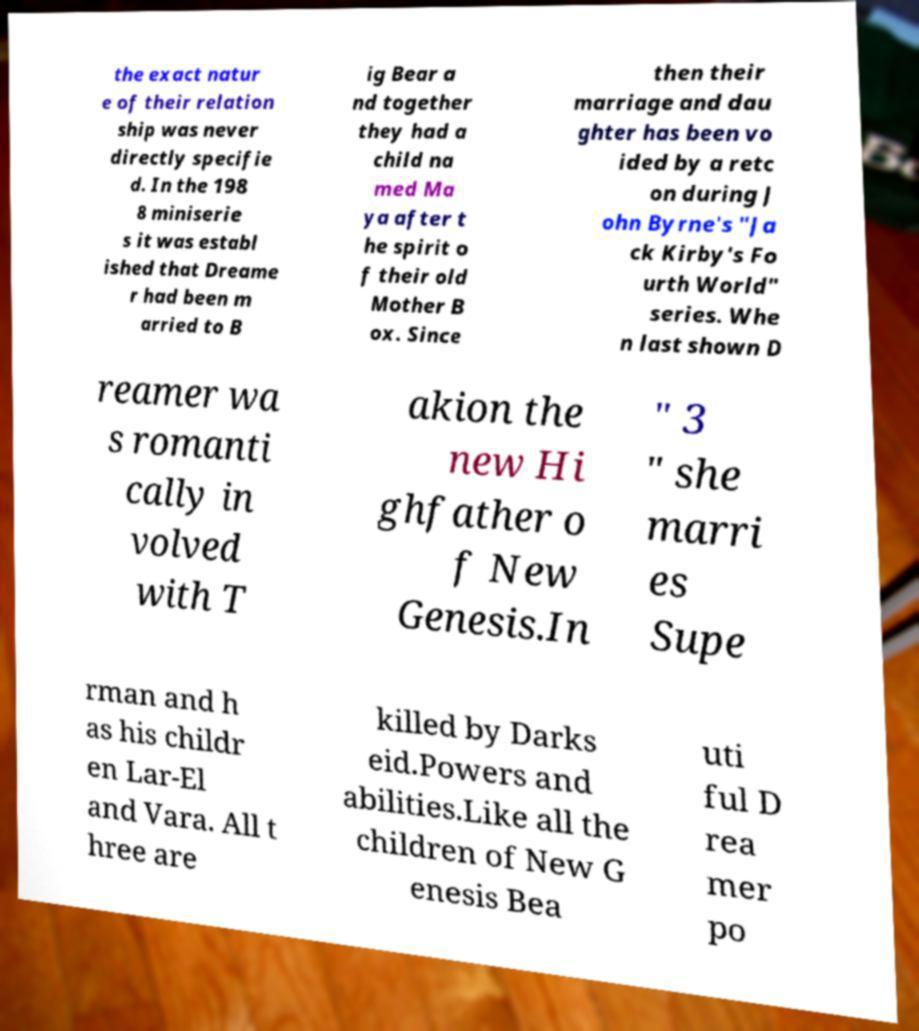Can you accurately transcribe the text from the provided image for me? the exact natur e of their relation ship was never directly specifie d. In the 198 8 miniserie s it was establ ished that Dreame r had been m arried to B ig Bear a nd together they had a child na med Ma ya after t he spirit o f their old Mother B ox. Since then their marriage and dau ghter has been vo ided by a retc on during J ohn Byrne's "Ja ck Kirby's Fo urth World" series. Whe n last shown D reamer wa s romanti cally in volved with T akion the new Hi ghfather o f New Genesis.In " 3 " she marri es Supe rman and h as his childr en Lar-El and Vara. All t hree are killed by Darks eid.Powers and abilities.Like all the children of New G enesis Bea uti ful D rea mer po 